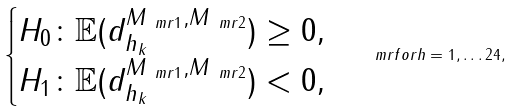<formula> <loc_0><loc_0><loc_500><loc_500>\begin{cases} H _ { 0 } \colon \mathbb { E } ( { d } ^ { M _ { \ m r { 1 } } , M _ { \ m r { 2 } } } _ { h _ { k } } ) \geq 0 , \\ H _ { 1 } \colon \mathbb { E } ( { d } ^ { M _ { \ m r { 1 } } , M _ { \ m r { 2 } } } _ { h _ { k } } ) < 0 , \end{cases} \ m r { f o r } h = 1 , \dots 2 4 ,</formula> 